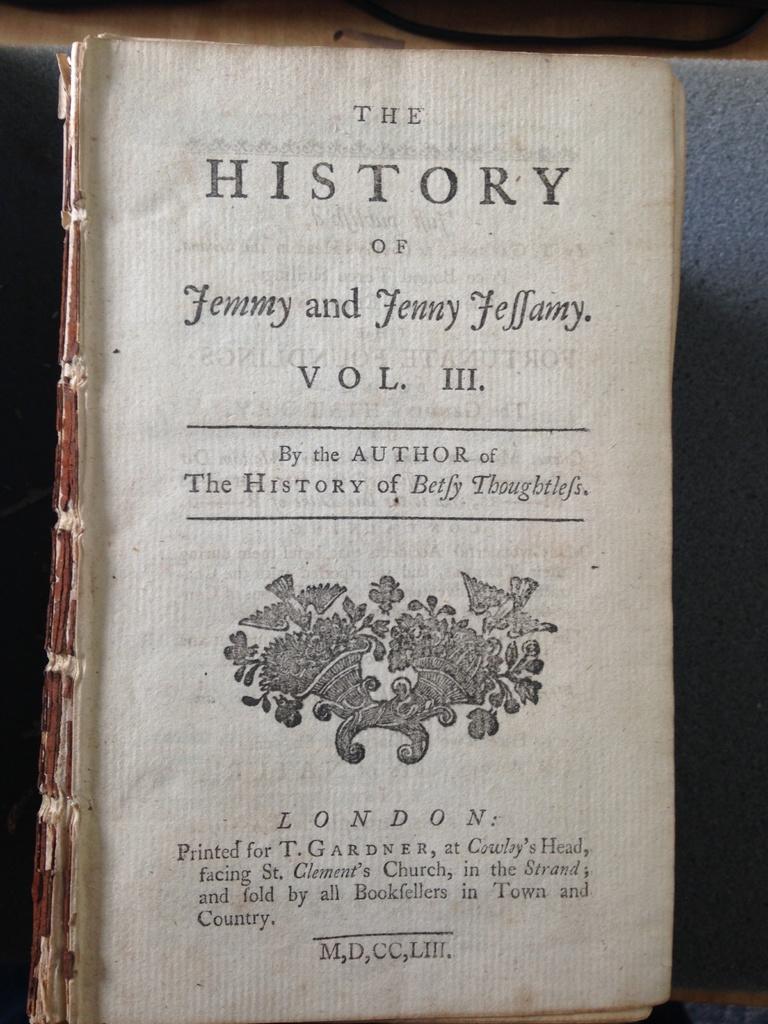What is this book a history of?
Provide a succinct answer. Jemmy and jenny jeffamy. Which volume is this book?
Give a very brief answer. 3. 